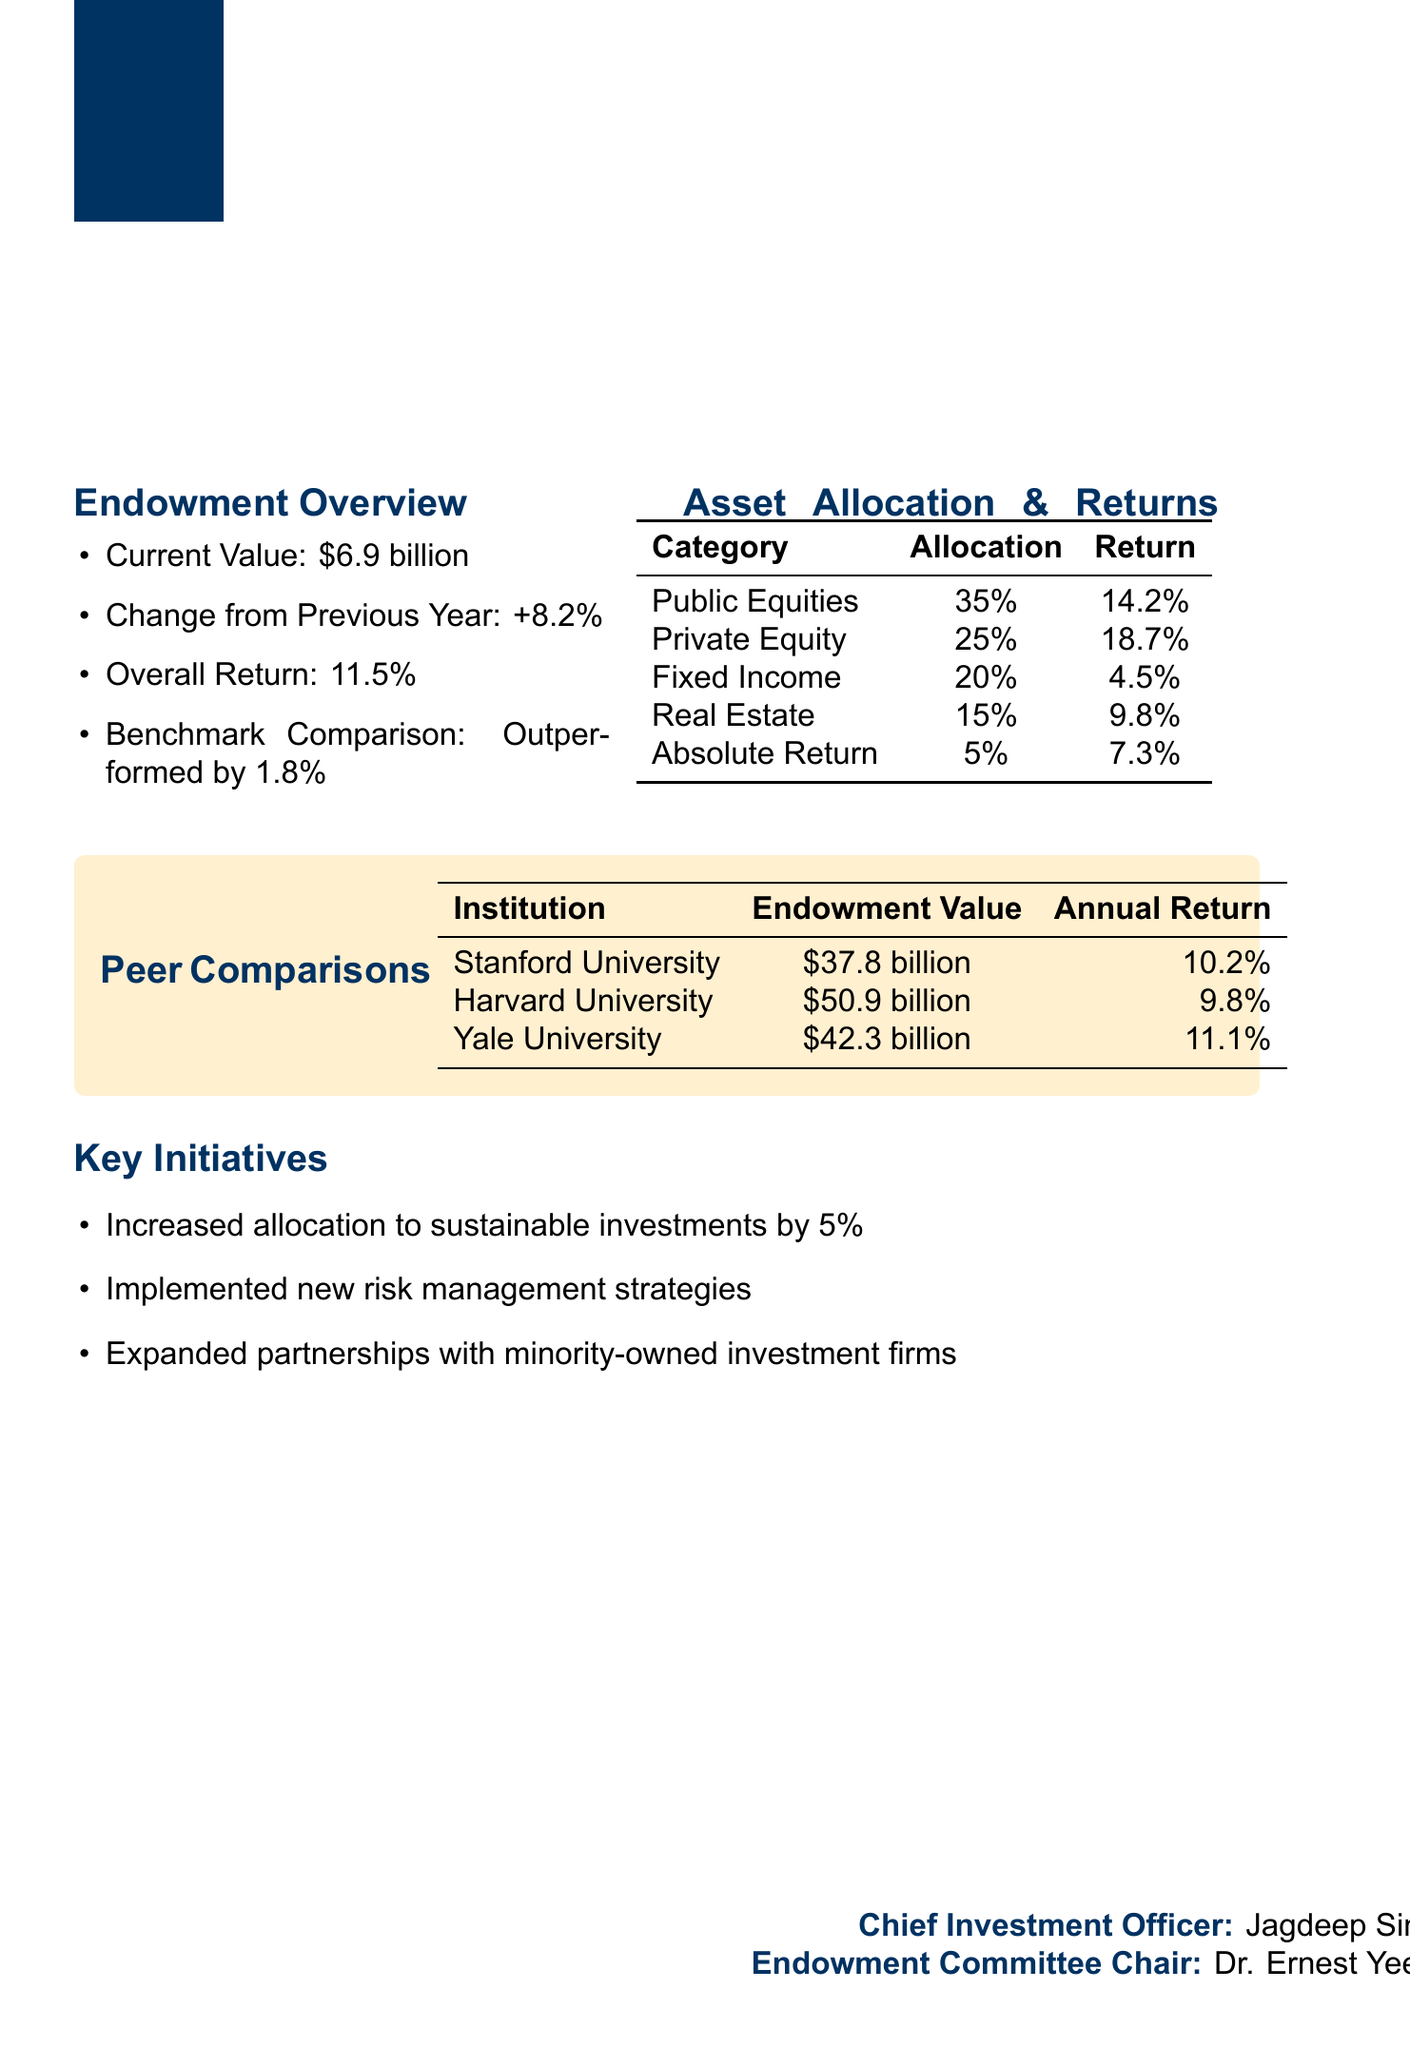what is the current value of the endowment? The current value of the endowment is explicitly stated in the document, which is $6.9 billion.
Answer: $6.9 billion who is the Chief Investment Officer? The document lists the Chief Investment Officer as Jagdeep Singh Bachher.
Answer: Jagdeep Singh Bachher what was the overall return for the fiscal year 2022-2023? The overall return for the fiscal year is mentioned as 11.5%.
Answer: 11.5% by how much did the university's endowment outperform the benchmark? The report states that the endowment outperformed the benchmark by 1.8%.
Answer: 1.8% which asset category had the highest return? The document provides returns for various asset categories, with Private Equity having the highest return at 18.7%.
Answer: Private Equity what percentage is allocated to Real Estate? The percentage allocation to Real Estate is noted in the asset allocation section, which is 15%.
Answer: 15% how does Berkeley's annual return compare to Yale University's? The comparisons between institutions indicate that Berkeley's return is higher than Yale's by 0.4% (11.5% vs. 11.1%).
Answer: Higher what is one of the key initiatives mentioned in the report? The document lists several initiatives, one of which is the increased allocation to sustainable investments by 5%.
Answer: Increased allocation to sustainable investments by 5% which institution has the highest endowment value among the peers listed? The endowment value comparison shows Harvard University with the highest value at $50.9 billion.
Answer: Harvard University 